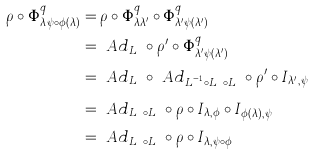Convert formula to latex. <formula><loc_0><loc_0><loc_500><loc_500>\rho \circ \Phi _ { \lambda \, \psi \circ \phi ( \lambda ) } ^ { q } & = \rho \circ \Phi _ { \lambda \lambda ^ { \prime } } ^ { q } \circ \Phi _ { \lambda ^ { \prime } \psi ( \lambda ^ { \prime } ) } ^ { q } \\ & = \ A d _ { L _ { \phi } } \circ \rho ^ { \prime } \circ \Phi _ { \lambda ^ { \prime } \psi ( \lambda ^ { \prime } ) } ^ { q } \\ & = \ A d _ { L _ { \phi } } \circ \ A d _ { L _ { \phi } ^ { - 1 } \circ L _ { \psi } \circ L _ { \phi } } \circ \rho ^ { \prime } \circ I _ { \lambda ^ { \prime } , \psi } \\ & = \ A d _ { L _ { \psi } \circ L _ { \phi } } \circ \rho \circ I _ { \lambda , \phi } \circ I _ { \phi ( \lambda ) , \psi } \\ & = \ A d _ { L _ { \psi } \circ L _ { \phi } } \circ \rho \circ I _ { \lambda , \psi \circ \phi }</formula> 